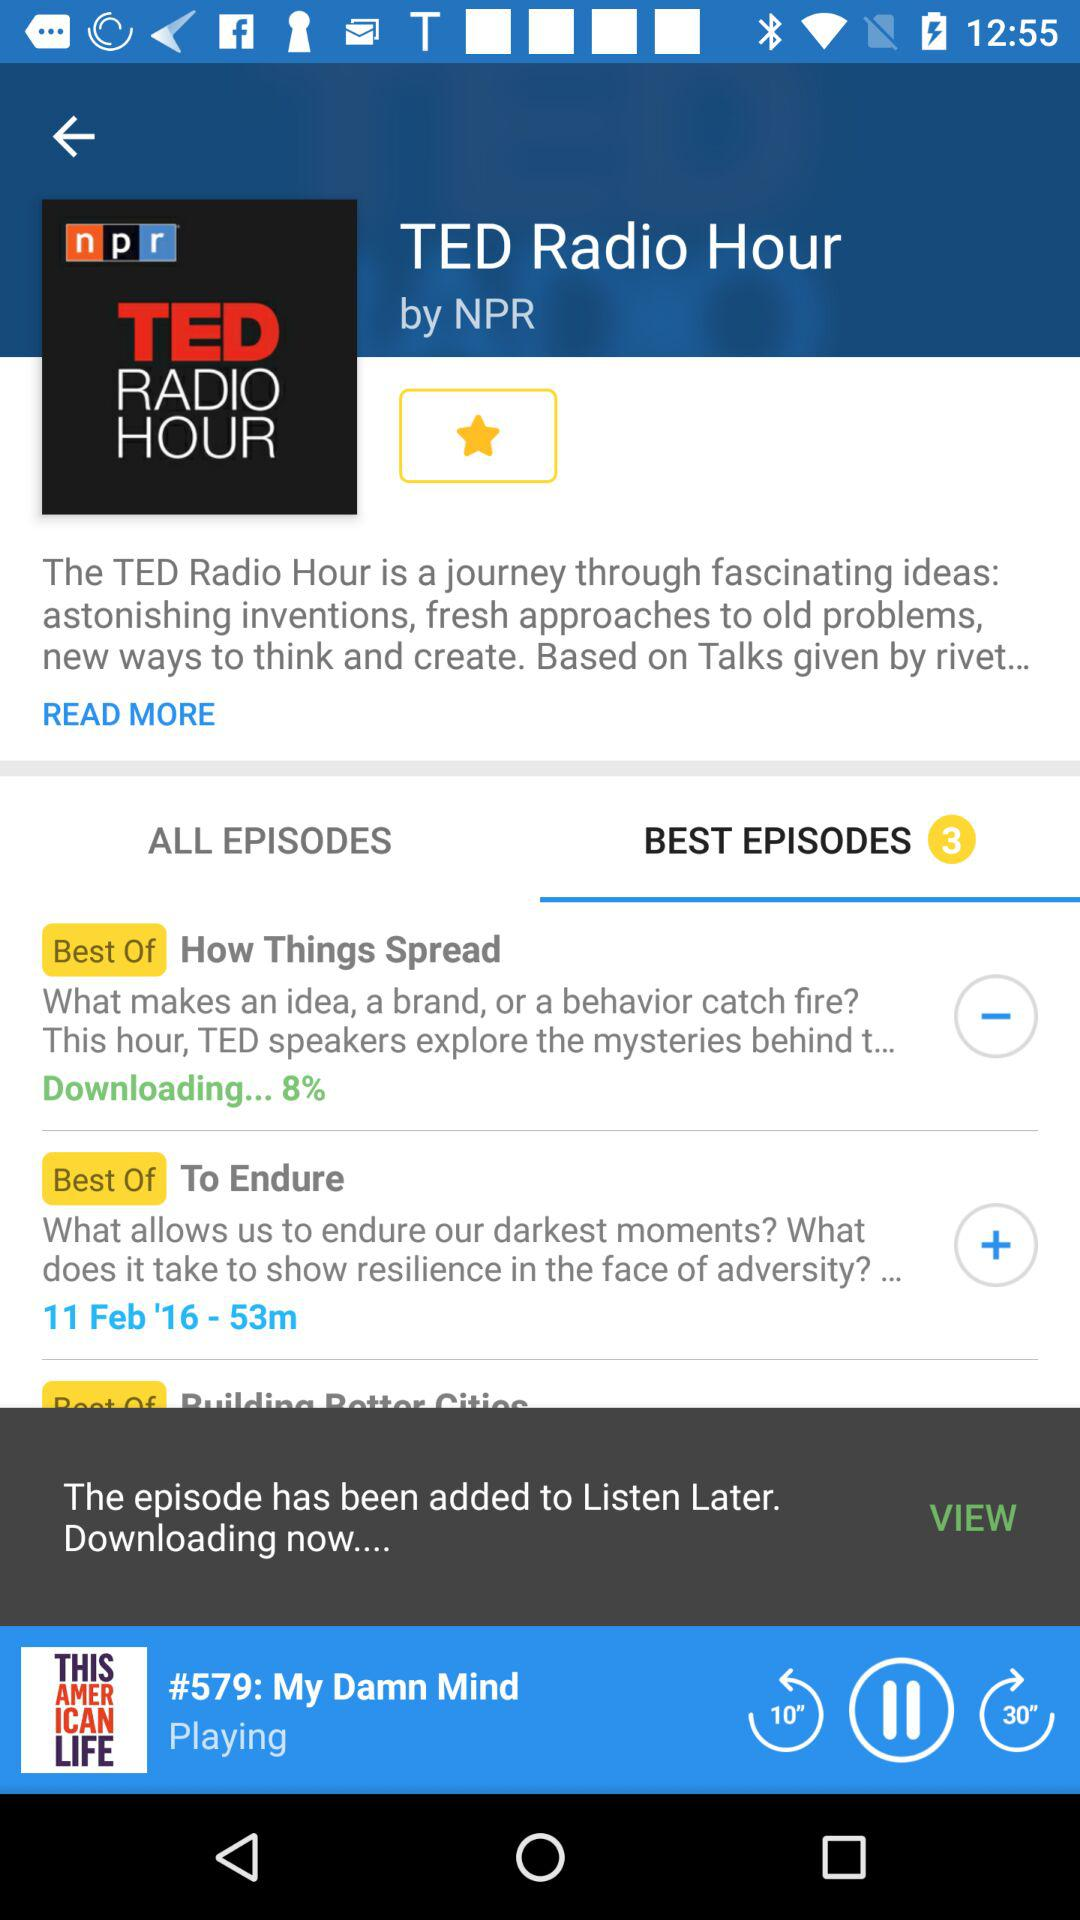What is the name of the program? The name of the program is "TED Radio Hour". 